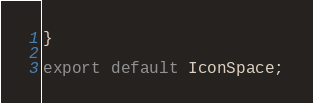<code> <loc_0><loc_0><loc_500><loc_500><_JavaScript_>}

export default IconSpace;</code> 